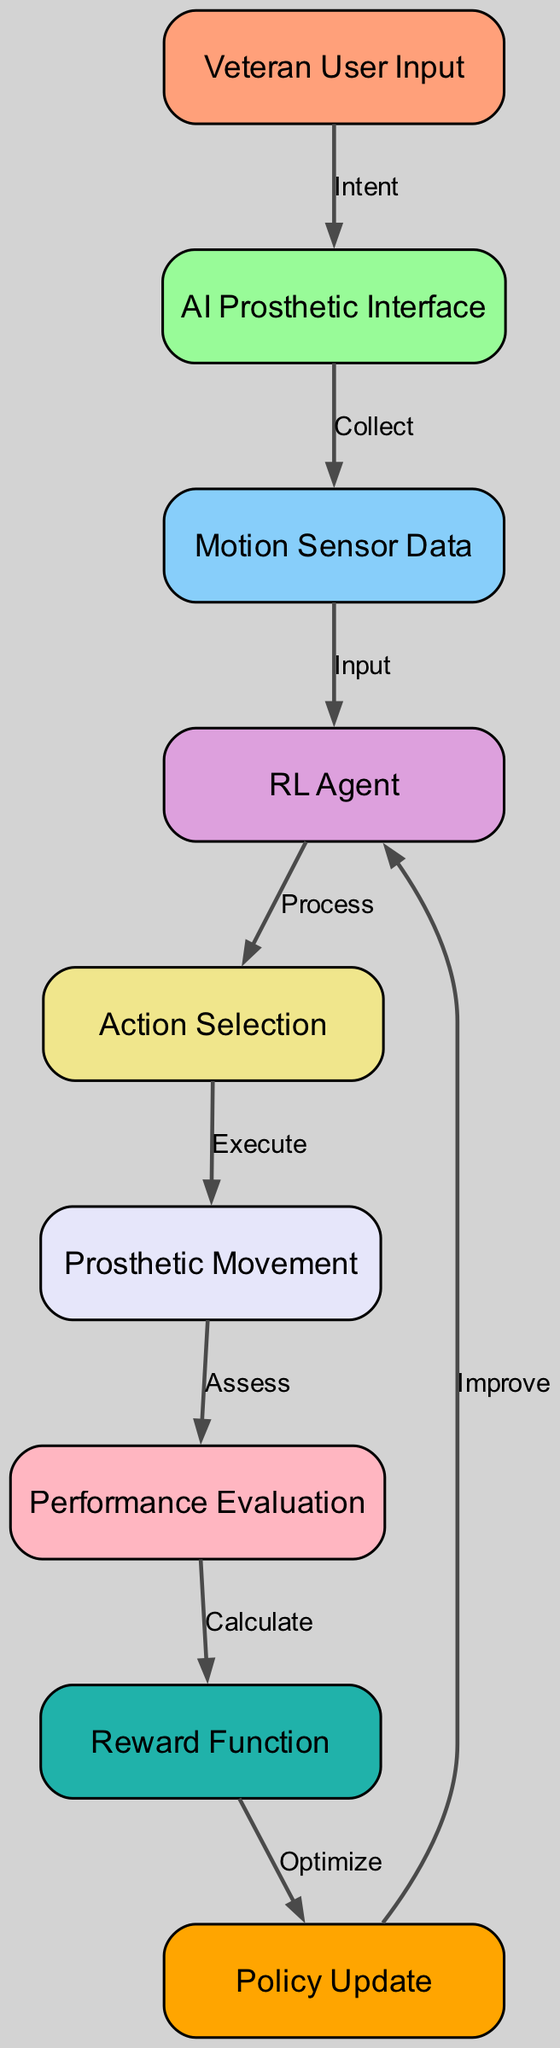What is the first node in the diagram? The first node is labeled "Veteran User Input." It's identified as node "1," which is positioned at the top of the diagram and indicates the source of input for the training process.
Answer: Veteran User Input How many nodes are present in the diagram? The diagram contains a total of nine nodes, identified numerically from 1 to 9. They represent various components of the reinforcement learning model for AI-powered prosthetics.
Answer: 9 What is the relationship between the "AI Prosthetic Interface" and "Motion Sensor Data"? The relationship is labeled "Collect." The edge connecting these two nodes indicates that the AI Prosthetic Interface collects motion sensor data to inform the RL agent’s processing.
Answer: Collect What action does the "RL Agent" perform after receiving the "Motion Sensor Data"? The RL Agent processes the data it receives; this action is indicated by the edge labeled "Process" that connects the "Motion Sensor Data" to the "Action Selection" node.
Answer: Process Which node follows "Performance Evaluation" in the sequence? The node that follows "Performance Evaluation" is "Reward Function." This is determined by tracing the edge labeled "Calculate" from the "Performance Evaluation" node to the "Reward Function" node.
Answer: Reward Function What is the final action taken by the RL Agent before returning to the beginning of the cycle? The final action is the policy update, which optimizes the current policy based on the feedback from the reward function, as indicated by the edge labeled "Optimize."
Answer: Policy Update What is the purpose of the "Reward Function" in the model? The purpose of the Reward Function is to calculate the rewards based on the performance evaluation of the prosthetic's actions. This function is crucial for guiding the agent's learning and decision-making process.
Answer: Calculate How does the "Prosthetic Movement" relate to the "Action Selection"? The relationship is labeled "Execute," indicating that the action selected by the RL Agent is executed as a movement of the prosthetic in response to the processed data.
Answer: Execute What component starts the adaptive training process in the diagram? The component that starts the adaptive training process is "Veteran User Input," which represents the intent of the veteran user and drives the subsequent data collection and processing actions.
Answer: Veteran User Input 